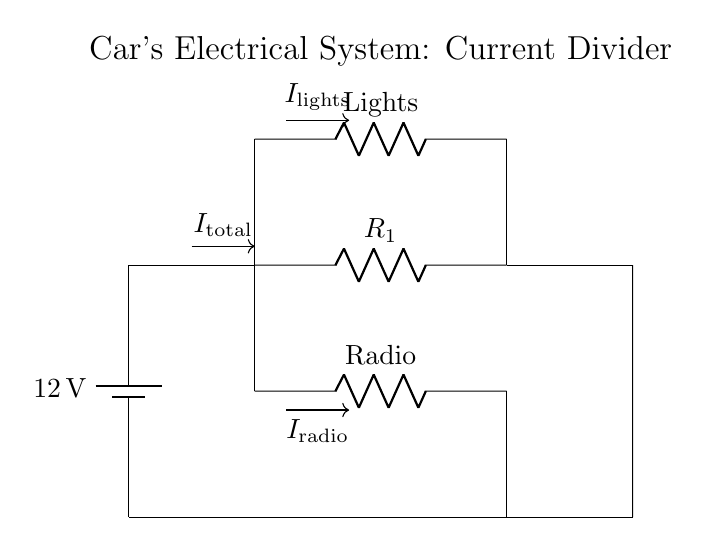What is the source voltage of the circuit? The source voltage in this circuit is given as 12V, which is indicated by the battery label.
Answer: 12V What components are in the radio branch? In the radio branch, there is a resistor labeled as "Radio" along with the connections leading to it.
Answer: Resistor How many branches does the current divide into? The circuit has two branches where the current divides: one for the radio and another for the dashboard lights.
Answer: Two What is the total current entering the circuit? The total current entering the circuit is labeled as I total, which is shown by the arrow pointing towards the junction at the top.
Answer: I total Which component is connected the lowest in this circuit? The lowest component in the circuit diagram is the resistor labeled as "Lights," which is located at the bottom of its respective branch.
Answer: Lights If the resistance of the radio branch is 4 Ohms and the lights branch is 8 Ohms, what is the relationship between the currents in each branch? To understand the relationship, we can use the current divider rule, which states that the current will divide inversely to the resistances. Thus, the current through the radio will be double that through the lights because 8 Ohms has a smaller current compared to 4 Ohms.
Answer: I radio = 2 * I lights Which branch has the higher voltage drop? Since both branches are powered by the same source voltage, and if we consider that under normal conditions with resistors in series, the branch with the lower resistance will have a higher voltage drop overall. Thus, the radio branch (assumed to be lower resistance) will have the higher voltage drop compared to the dashboard lights branch.
Answer: Radio branch 